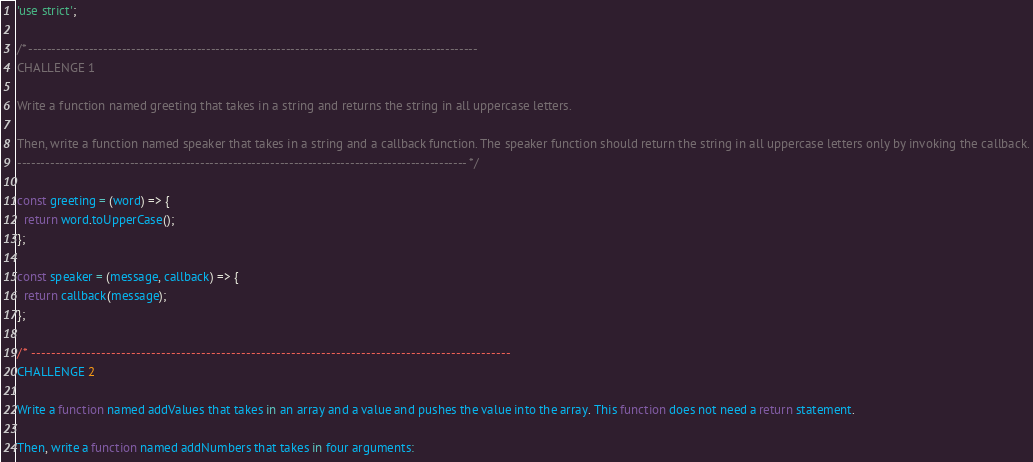<code> <loc_0><loc_0><loc_500><loc_500><_JavaScript_>'use strict';

/* ------------------------------------------------------------------------------------------------
CHALLENGE 1

Write a function named greeting that takes in a string and returns the string in all uppercase letters.

Then, write a function named speaker that takes in a string and a callback function. The speaker function should return the string in all uppercase letters only by invoking the callback.
------------------------------------------------------------------------------------------------ */

const greeting = (word) => {
  return word.toUpperCase();
};

const speaker = (message, callback) => {
  return callback(message);
};

/* ------------------------------------------------------------------------------------------------
CHALLENGE 2

Write a function named addValues that takes in an array and a value and pushes the value into the array. This function does not need a return statement.

Then, write a function named addNumbers that takes in four arguments:</code> 